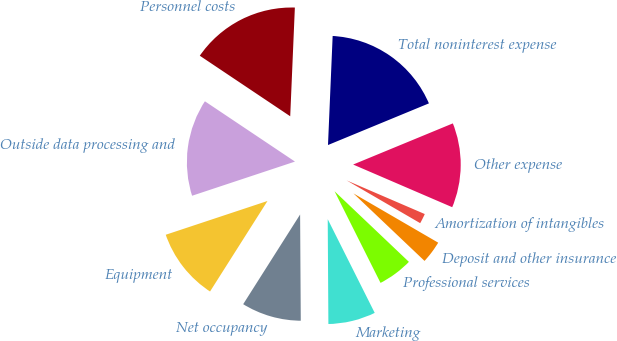<chart> <loc_0><loc_0><loc_500><loc_500><pie_chart><fcel>Personnel costs<fcel>Outside data processing and<fcel>Equipment<fcel>Net occupancy<fcel>Marketing<fcel>Professional services<fcel>Deposit and other insurance<fcel>Amortization of intangibles<fcel>Other expense<fcel>Total noninterest expense<nl><fcel>16.29%<fcel>14.49%<fcel>10.9%<fcel>9.1%<fcel>7.3%<fcel>5.51%<fcel>3.71%<fcel>1.91%<fcel>12.7%<fcel>18.09%<nl></chart> 